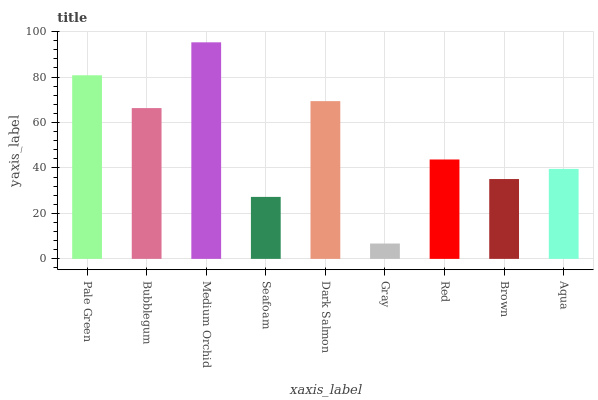Is Gray the minimum?
Answer yes or no. Yes. Is Medium Orchid the maximum?
Answer yes or no. Yes. Is Bubblegum the minimum?
Answer yes or no. No. Is Bubblegum the maximum?
Answer yes or no. No. Is Pale Green greater than Bubblegum?
Answer yes or no. Yes. Is Bubblegum less than Pale Green?
Answer yes or no. Yes. Is Bubblegum greater than Pale Green?
Answer yes or no. No. Is Pale Green less than Bubblegum?
Answer yes or no. No. Is Red the high median?
Answer yes or no. Yes. Is Red the low median?
Answer yes or no. Yes. Is Medium Orchid the high median?
Answer yes or no. No. Is Aqua the low median?
Answer yes or no. No. 